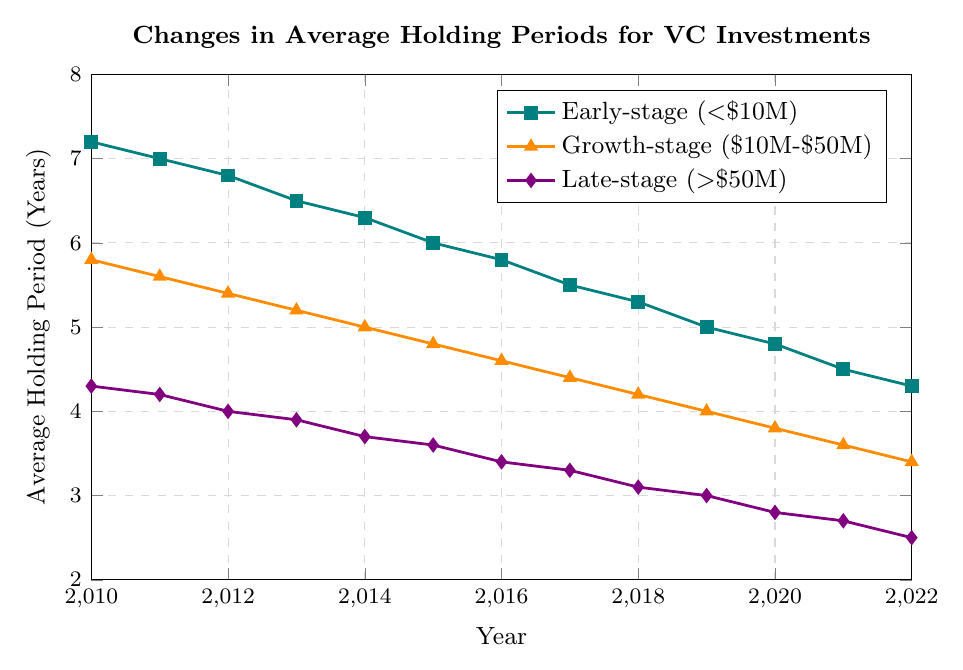What is the average holding period for Early-stage companies in 2014? From the chart, the value for Early-stage (\<$10M) companies in 2014 is 6.3 years.
Answer: 6.3 years How does the average holding period for Growth-stage companies change from 2010 to 2022? In 2010, the average holding period for Growth-stage companies was 5.8 years, and it decreased steadily every year to 3.4 years in 2022.
Answer: Decrease from 5.8 years to 3.4 years In which year did Late-stage companies have the shortest average holding period? Late-stage (>\$50M) companies achieved their shortest average holding period of 2.5 years in 2022 based on the downward trend in the chart.
Answer: 2022 Compare the average holding periods for Early-stage and Late-stage companies in 2015. Which was longer and by how much? In 2015, the Early-stage average holding period was 6.0 years, while the Late-stage average holding period was 3.6 years. The difference is 6.0 - 3.6 = 2.4 years.
Answer: Early-stage by 2.4 years What was the trend in the average holding period for all three company sizes from 2010 to 2022? The chart shows a consistent downward trend in the average holding periods for all three company sizes (Early-stage, Growth-stage, and Late-stage) from 2010 to 2022.
Answer: Downward trend How much did the average holding period decrease for Early-stage companies between 2010 and 2020? For Early-stage companies, the average holding period in 2010 was 7.2 years, and it decreased to 4.8 years by 2020. The decrease is 7.2 - 4.8 = 2.4 years.
Answer: 2.4 years Which company size had the most significant reduction in the average holding period from 2010 to 2022? The Late-stage companies saw the greatest reduction in average holding period, reducing from 4.3 years in 2010 to 2.5 years in 2022. The reduction is 4.3 - 2.5 = 1.8 years.
Answer: Late-stage companies What are the visual indicators used to distinguish different company sizes in the chart? The chart uses distinct colors and different markers (square for Early-stage, triangle for Growth-stage, and diamond for Late-stage) to differentiate between the company sizes.
Answer: Colors and markers What is the difference in the average holding period for Growth-stage companies between the years 2011 and 2021? The average holding period for Growth-stage companies was 5.6 years in 2011 and 3.6 years in 2021. The difference is 5.6 - 3.6 = 2.0 years.
Answer: 2.0 years In what year did Early-stage companies fall below an average holding period of 5 years? From the chart, Early-stage companies had an average holding period of 5.3 years in 2018, which then dropped to 5.0 years in 2019, falling below 5 years around 2019.
Answer: 2019 